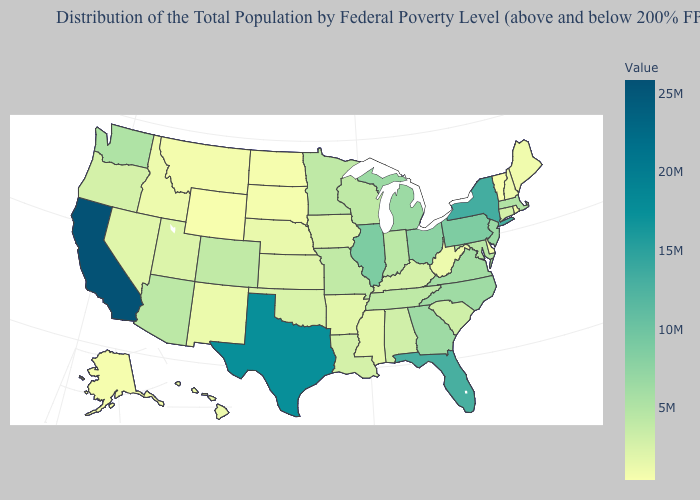Which states have the lowest value in the Northeast?
Short answer required. Vermont. Which states have the lowest value in the MidWest?
Answer briefly. North Dakota. Does California have the highest value in the West?
Be succinct. Yes. Does New Jersey have the highest value in the Northeast?
Quick response, please. No. Does Wyoming have the lowest value in the West?
Short answer required. Yes. Among the states that border Kentucky , does Illinois have the highest value?
Quick response, please. Yes. Does Vermont have the lowest value in the Northeast?
Keep it brief. Yes. 